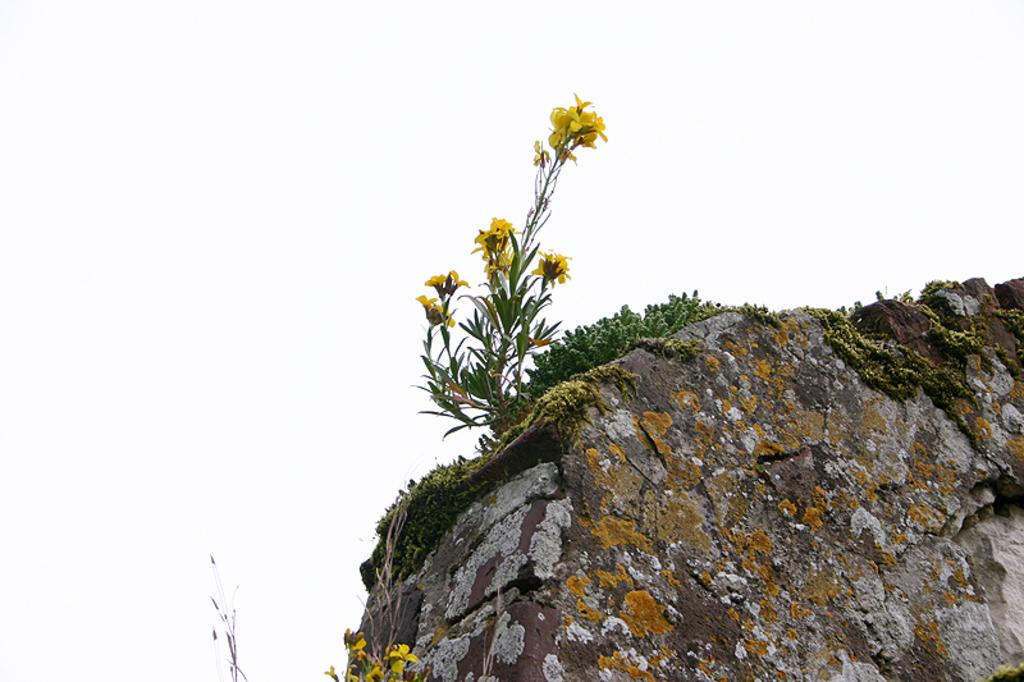Where was the picture taken? The picture was clicked outside. What can be seen in the foreground of the image? There are flowers, green leaves, and rocks in the foreground of the image. What is visible in the background of the image? The sky is visible in the background of the image. How many rabbits can be seen playing with the father in the image? There are no rabbits or a father present in the image. What is the desire of the flowers in the image? The image does not depict the desires of the flowers; it only shows their presence in the foreground. 